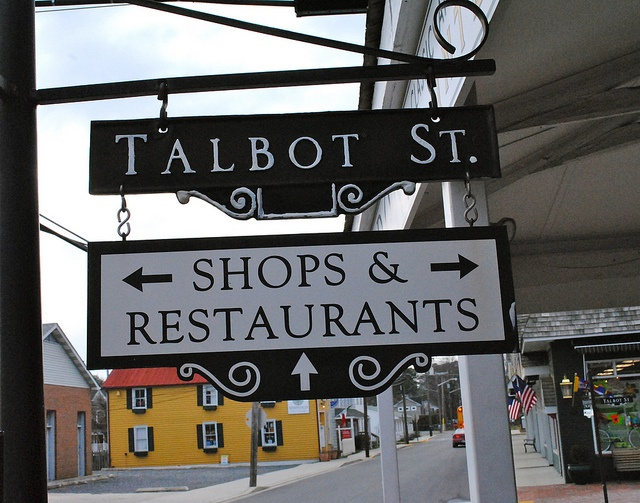Describe the objects in this image and their specific colors. I can see bench in black and gray tones, bicycle in black, gray, darkgreen, and teal tones, car in black and gray tones, car in black, maroon, gray, and darkgray tones, and bench in black and gray tones in this image. 